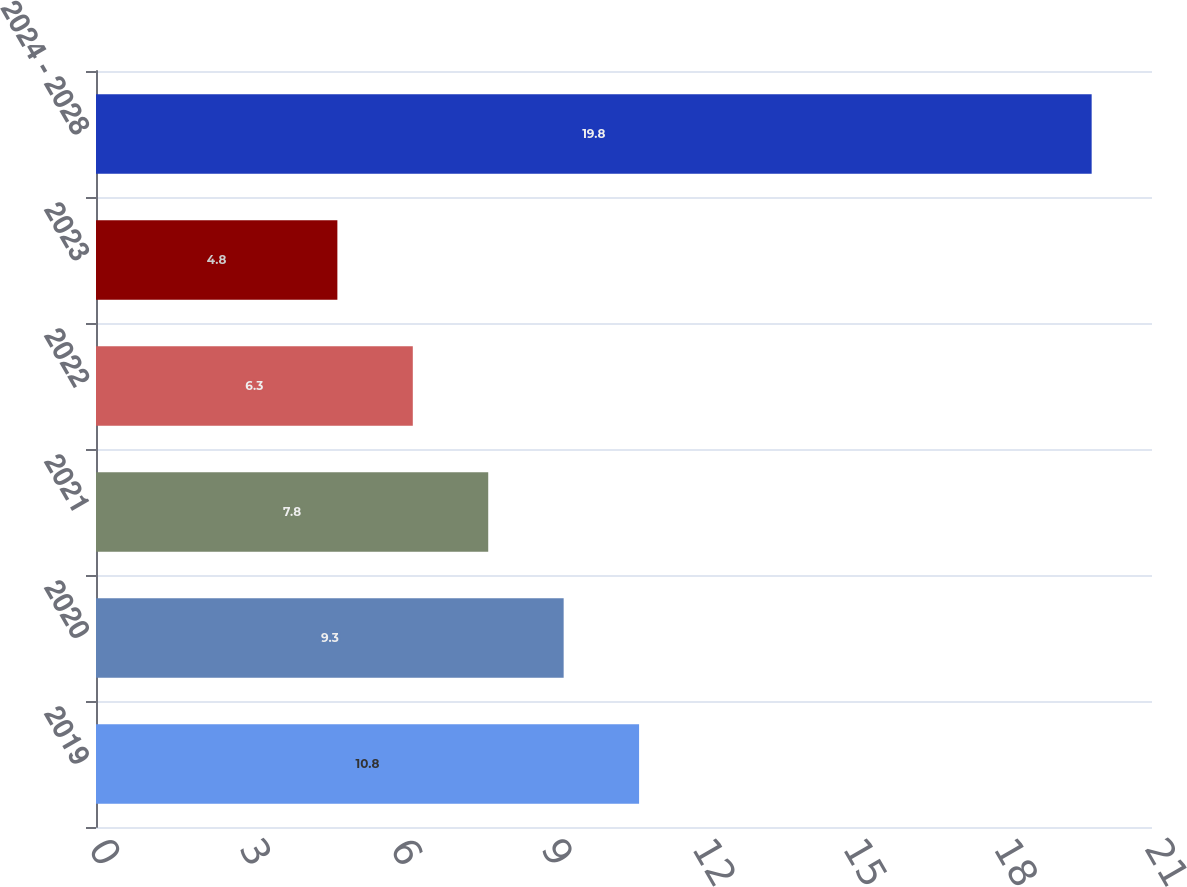<chart> <loc_0><loc_0><loc_500><loc_500><bar_chart><fcel>2019<fcel>2020<fcel>2021<fcel>2022<fcel>2023<fcel>2024 - 2028<nl><fcel>10.8<fcel>9.3<fcel>7.8<fcel>6.3<fcel>4.8<fcel>19.8<nl></chart> 